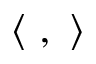Convert formula to latex. <formula><loc_0><loc_0><loc_500><loc_500>\langle , \rangle</formula> 